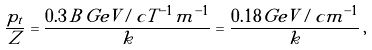Convert formula to latex. <formula><loc_0><loc_0><loc_500><loc_500>\frac { p _ { t } } { Z } = \frac { 0 . 3 \, B \, G e V / c T ^ { - 1 } m ^ { - 1 } } { k } = \frac { 0 . 1 8 \, G e V / c m ^ { - 1 } } { k } \, ,</formula> 